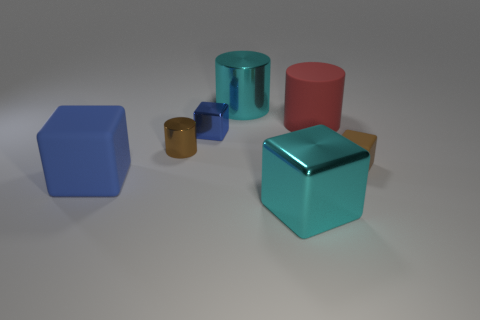How many things are either cyan things behind the big blue rubber block or tiny gray cubes?
Give a very brief answer. 1. Is the number of tiny purple matte balls less than the number of cyan metal cylinders?
Your answer should be compact. Yes. There is a big rubber object that is on the right side of the large metal object that is right of the big cyan object behind the big blue matte block; what shape is it?
Give a very brief answer. Cylinder. There is a thing that is the same color as the big metallic cylinder; what is its shape?
Ensure brevity in your answer.  Cube. Is there a large matte block?
Your answer should be compact. Yes. There is a brown cube; does it have the same size as the metal cube that is behind the big cyan shiny block?
Make the answer very short. Yes. There is a large cylinder that is right of the large cyan metallic cube; is there a cylinder that is on the left side of it?
Provide a short and direct response. Yes. There is a object that is to the left of the small brown rubber cube and to the right of the large cyan cube; what is its material?
Give a very brief answer. Rubber. What is the color of the cube in front of the blue object that is in front of the tiny block that is behind the tiny rubber thing?
Your answer should be compact. Cyan. What is the color of the other block that is the same size as the brown rubber block?
Provide a succinct answer. Blue. 